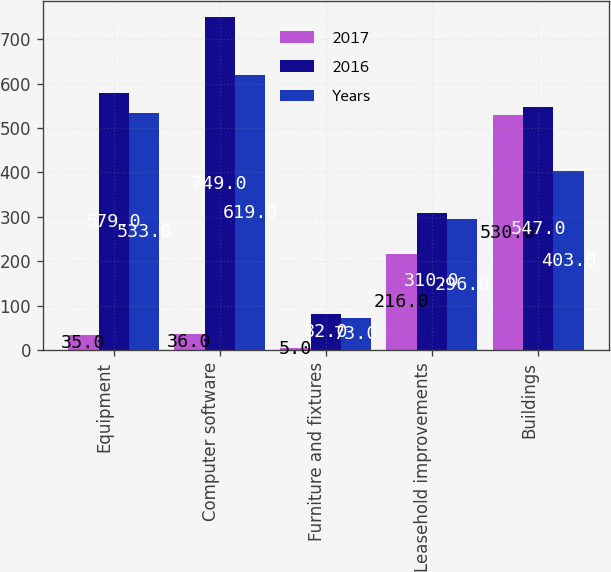Convert chart to OTSL. <chart><loc_0><loc_0><loc_500><loc_500><stacked_bar_chart><ecel><fcel>Equipment<fcel>Computer software<fcel>Furniture and fixtures<fcel>Leasehold improvements<fcel>Buildings<nl><fcel>2017<fcel>35<fcel>36<fcel>5<fcel>216<fcel>530<nl><fcel>2016<fcel>579<fcel>749<fcel>82<fcel>310<fcel>547<nl><fcel>Years<fcel>533<fcel>619<fcel>73<fcel>296<fcel>403<nl></chart> 